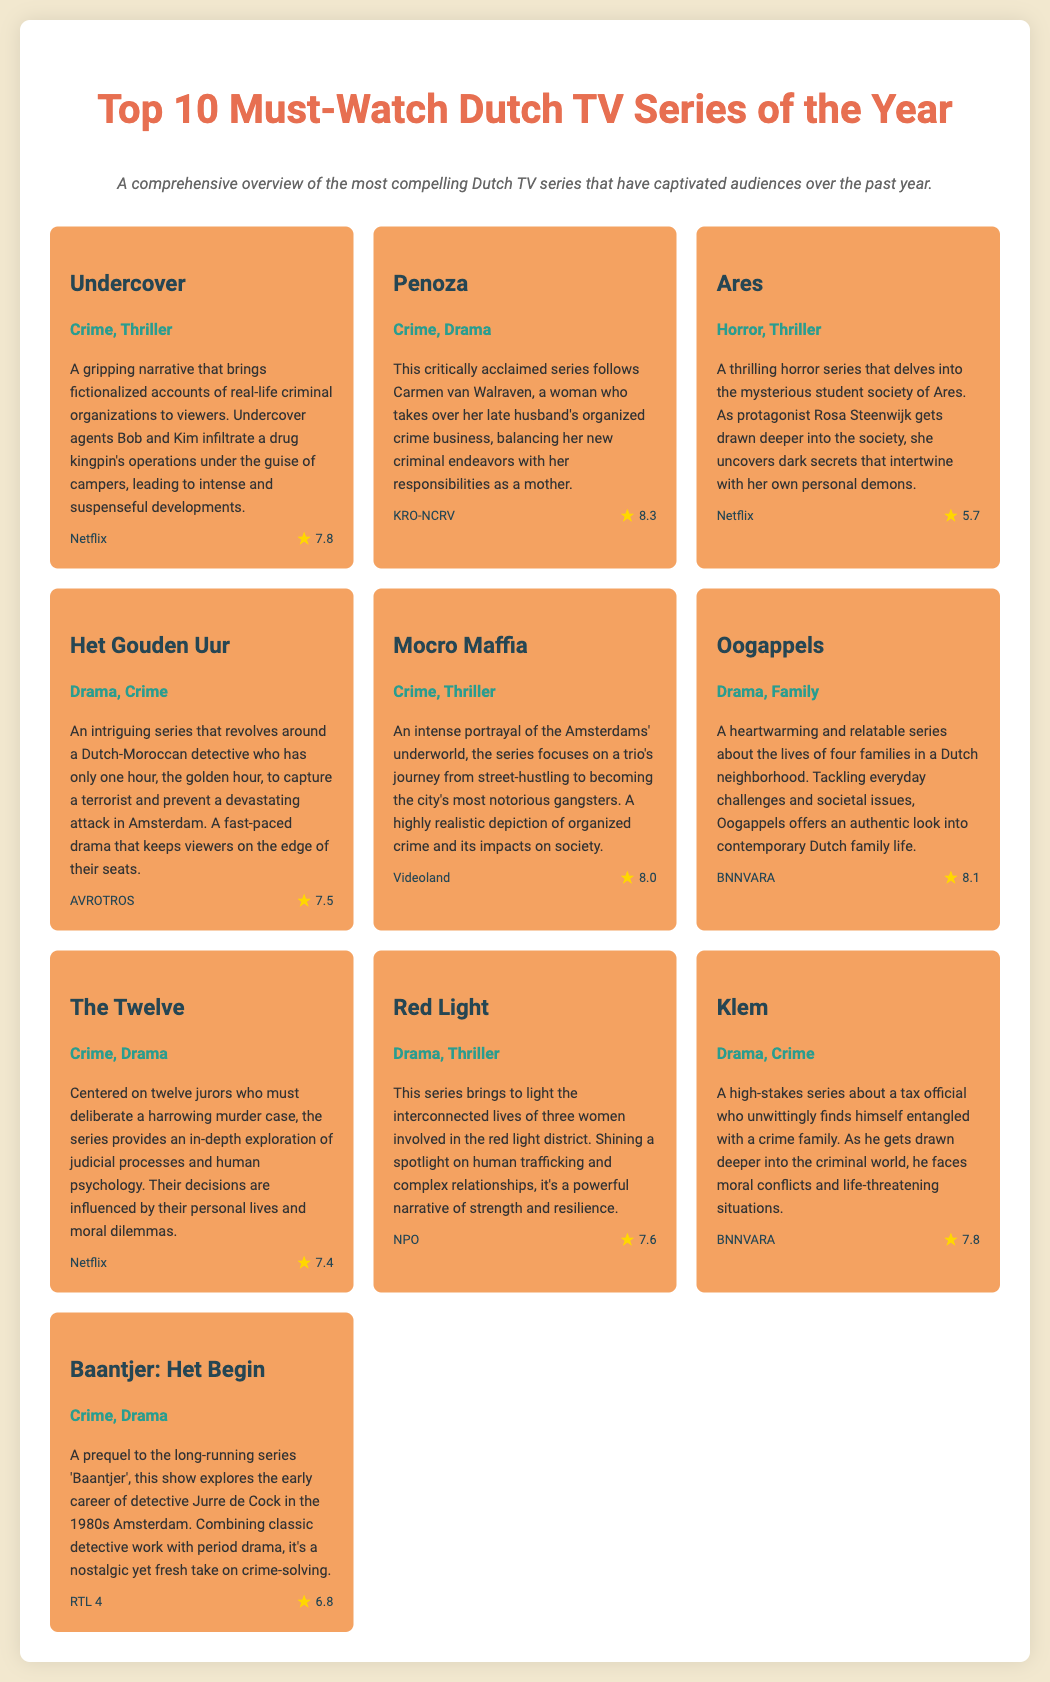What is the genre of "Undercover"? The genre of "Undercover" is mentioned in the document as Crime, Thriller.
Answer: Crime, Thriller What is the rating of "Penoza"? The document lists the rating of "Penoza" as 8.3.
Answer: 8.3 Which platform airs "Oogappels"? According to the document, "Oogappels" is aired on BNNVARA.
Answer: BNNVARA What is the main theme of "Ares"? The document describes "Ares" as delving into the mysterious student society and reveals dark secrets.
Answer: Mysterious student society Which show has a lower rating, "The Twelve" or "Klem"? By comparing the ratings provided in the document, "The Twelve" has a rating of 7.4 and "Klem" has a rating of 7.8, making "The Twelve" lower.
Answer: The Twelve What connection do the series "Red Light" and "Undercover" share? Both series focus on crime and its social implications, highlighting serious societal issues.
Answer: Crime What year does "Baantjer: Het Begin" take place? The document states that "Baantjer: Het Begin" explores the early career of the detective in the 1980s.
Answer: 1980s 